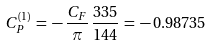Convert formula to latex. <formula><loc_0><loc_0><loc_500><loc_500>C _ { P } ^ { ( 1 ) } \, = \, - \, \frac { C _ { F } } { \pi } \, \frac { 3 3 5 } { 1 4 4 } \, = \, - \, 0 . 9 8 7 3 5</formula> 